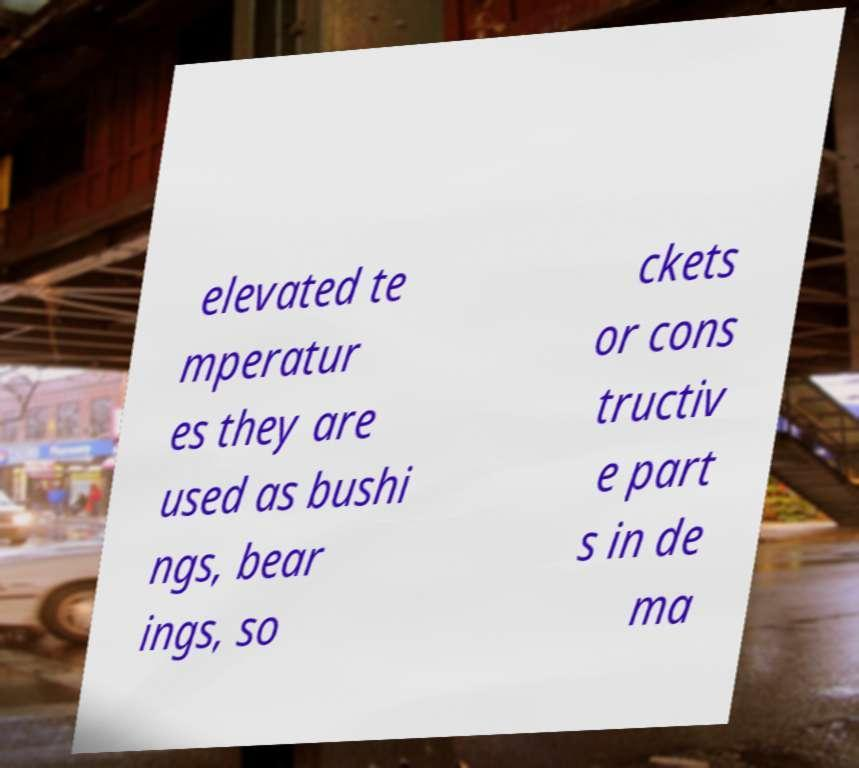For documentation purposes, I need the text within this image transcribed. Could you provide that? elevated te mperatur es they are used as bushi ngs, bear ings, so ckets or cons tructiv e part s in de ma 